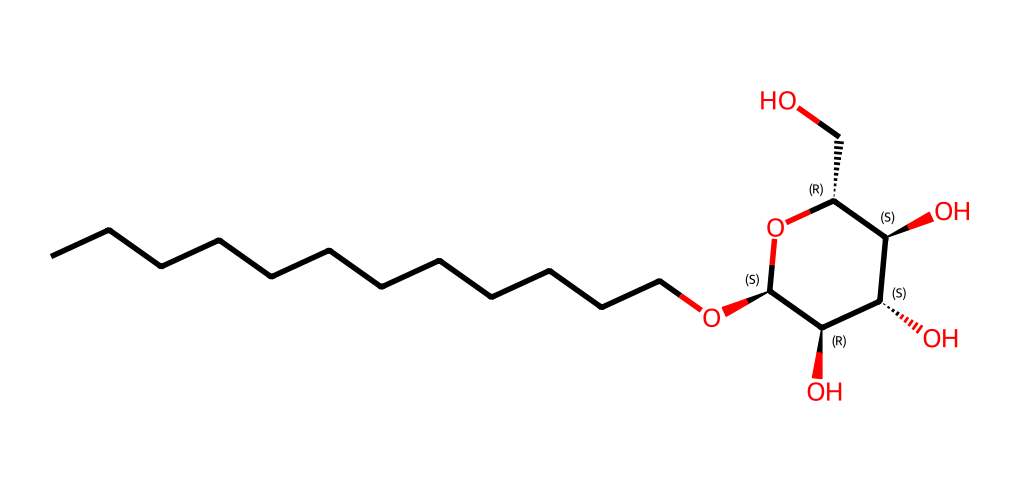What is the molecular formula of the compound represented? To determine the molecular formula, we count the number of each type of atom in the SMILES representation. The structure indicates there are 16 carbon (C) atoms, 32 hydrogen (H) atoms, and 6 oxygen (O) atoms. Therefore, the molecular formula is C16H32O6.
Answer: C16H32O6 How many chiral centers does the molecule have? By examining the structure, we identify the chiral centers, which are typically carbon atoms bonded to four different substituents. In the given structure, there are four such carbon atoms, indicating four chiral centers in total.
Answer: 4 What type of surfactant is this compound classified as? Given that the compound features a hydrophilic head (the polyglucoside part) and a hydrophobic tail (the alkyl chain), it is recognized as a non-ionic surfactant because it does not contain ionic charged groups.
Answer: non-ionic How does the alkyl chain length affect the surfactant's properties? The length of the alkyl chain influences the surfactant's hydrophobicity and thus its cleansing efficiency. In this case, the long carbon chain (12 carbons) contributes to effective surfactant properties but can also increase the emulsification capability and foaming qualities of the detergent.
Answer: increases effectiveness What role do the hydroxyl groups play in this molecule? The hydroxyl groups (-OH) in the molecule enhance its hydrophilicity, improving the surfactant's ability to interact with water and solubilize oils, which is critical for its performance as a detergent. Thus, they facilitate the emulsification process and increase solubility.
Answer: enhance hydrophilicity Does this molecule have any functional groups besides alkyl and hydroxyl? The molecule also contains glycosidic linkages as indicated by the ether bonds (-O-) connecting the sugar units, which is characteristic of polyglucosides and contributes to its non-ionic nature.
Answer: glycosidic linkages What is the primary source of the ingredients in this surfactant? Alkyl polyglucosides are derived from natural sources, primarily plant materials such as corn or potato starch, which provide the glucose units, while the alkyl portion is sourced from natural fatty alcohols.
Answer: plant materials 